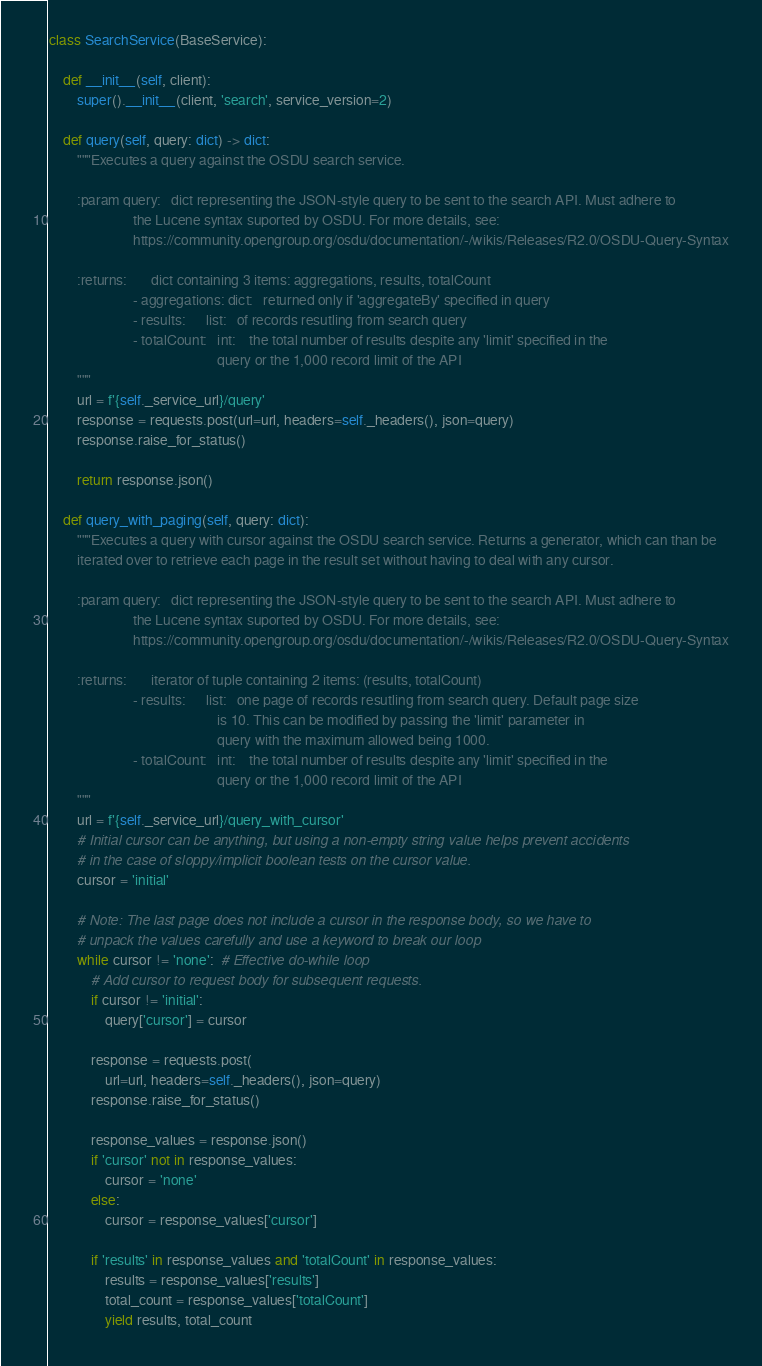Convert code to text. <code><loc_0><loc_0><loc_500><loc_500><_Python_>class SearchService(BaseService):

    def __init__(self, client):
        super().__init__(client, 'search', service_version=2)

    def query(self, query: dict) -> dict:
        """Executes a query against the OSDU search service.

        :param query:   dict representing the JSON-style query to be sent to the search API. Must adhere to
                        the Lucene syntax suported by OSDU. For more details, see: 
                        https://community.opengroup.org/osdu/documentation/-/wikis/Releases/R2.0/OSDU-Query-Syntax

        :returns:       dict containing 3 items: aggregations, results, totalCount
                        - aggregations: dict:   returned only if 'aggregateBy' specified in query
                        - results:      list:   of records resutling from search query  
                        - totalCount:   int:    the total number of results despite any 'limit' specified in the
                                                query or the 1,000 record limit of the API
        """
        url = f'{self._service_url}/query'
        response = requests.post(url=url, headers=self._headers(), json=query)
        response.raise_for_status()

        return response.json()

    def query_with_paging(self, query: dict):
        """Executes a query with cursor against the OSDU search service. Returns a generator, which can than be
        iterated over to retrieve each page in the result set without having to deal with any cursor.

        :param query:   dict representing the JSON-style query to be sent to the search API. Must adhere to
                        the Lucene syntax suported by OSDU. For more details, see: 
                        https://community.opengroup.org/osdu/documentation/-/wikis/Releases/R2.0/OSDU-Query-Syntax

        :returns:       iterator of tuple containing 2 items: (results, totalCount)
                        - results:      list:   one page of records resutling from search query. Default page size
                                                is 10. This can be modified by passing the 'limit' parameter in
                                                query with the maximum allowed being 1000.
                        - totalCount:   int:    the total number of results despite any 'limit' specified in the
                                                query or the 1,000 record limit of the API
        """
        url = f'{self._service_url}/query_with_cursor'
        # Initial cursor can be anything, but using a non-empty string value helps prevent accidents
        # in the case of sloppy/implicit boolean tests on the cursor value.
        cursor = 'initial'

        # Note: The last page does not include a cursor in the response body, so we have to
        # unpack the values carefully and use a keyword to break our loop
        while cursor != 'none':  # Effective do-while loop
            # Add cursor to request body for subsequent requests.
            if cursor != 'initial':
                query['cursor'] = cursor

            response = requests.post(
                url=url, headers=self._headers(), json=query)
            response.raise_for_status()

            response_values = response.json()
            if 'cursor' not in response_values:
                cursor = 'none'
            else:
                cursor = response_values['cursor']

            if 'results' in response_values and 'totalCount' in response_values:
                results = response_values['results']
                total_count = response_values['totalCount']
                yield results, total_count
</code> 